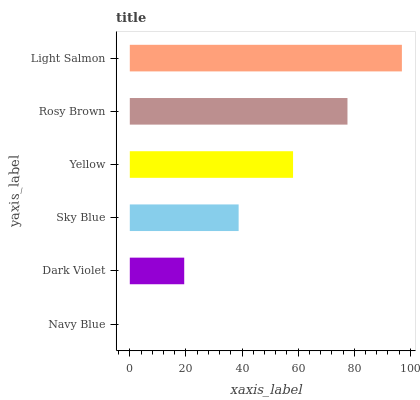Is Navy Blue the minimum?
Answer yes or no. Yes. Is Light Salmon the maximum?
Answer yes or no. Yes. Is Dark Violet the minimum?
Answer yes or no. No. Is Dark Violet the maximum?
Answer yes or no. No. Is Dark Violet greater than Navy Blue?
Answer yes or no. Yes. Is Navy Blue less than Dark Violet?
Answer yes or no. Yes. Is Navy Blue greater than Dark Violet?
Answer yes or no. No. Is Dark Violet less than Navy Blue?
Answer yes or no. No. Is Yellow the high median?
Answer yes or no. Yes. Is Sky Blue the low median?
Answer yes or no. Yes. Is Sky Blue the high median?
Answer yes or no. No. Is Navy Blue the low median?
Answer yes or no. No. 